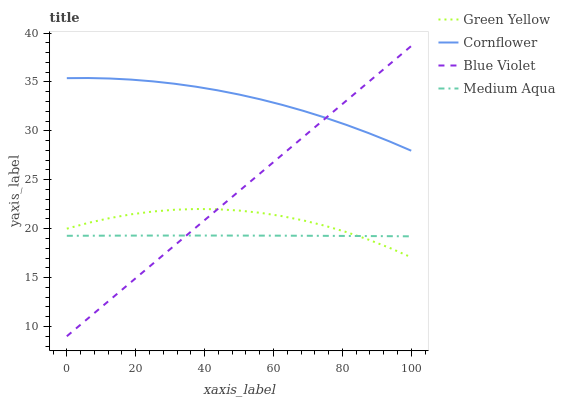Does Medium Aqua have the minimum area under the curve?
Answer yes or no. Yes. Does Cornflower have the maximum area under the curve?
Answer yes or no. Yes. Does Green Yellow have the minimum area under the curve?
Answer yes or no. No. Does Green Yellow have the maximum area under the curve?
Answer yes or no. No. Is Blue Violet the smoothest?
Answer yes or no. Yes. Is Green Yellow the roughest?
Answer yes or no. Yes. Is Medium Aqua the smoothest?
Answer yes or no. No. Is Medium Aqua the roughest?
Answer yes or no. No. Does Blue Violet have the lowest value?
Answer yes or no. Yes. Does Green Yellow have the lowest value?
Answer yes or no. No. Does Blue Violet have the highest value?
Answer yes or no. Yes. Does Green Yellow have the highest value?
Answer yes or no. No. Is Green Yellow less than Cornflower?
Answer yes or no. Yes. Is Cornflower greater than Medium Aqua?
Answer yes or no. Yes. Does Blue Violet intersect Cornflower?
Answer yes or no. Yes. Is Blue Violet less than Cornflower?
Answer yes or no. No. Is Blue Violet greater than Cornflower?
Answer yes or no. No. Does Green Yellow intersect Cornflower?
Answer yes or no. No. 